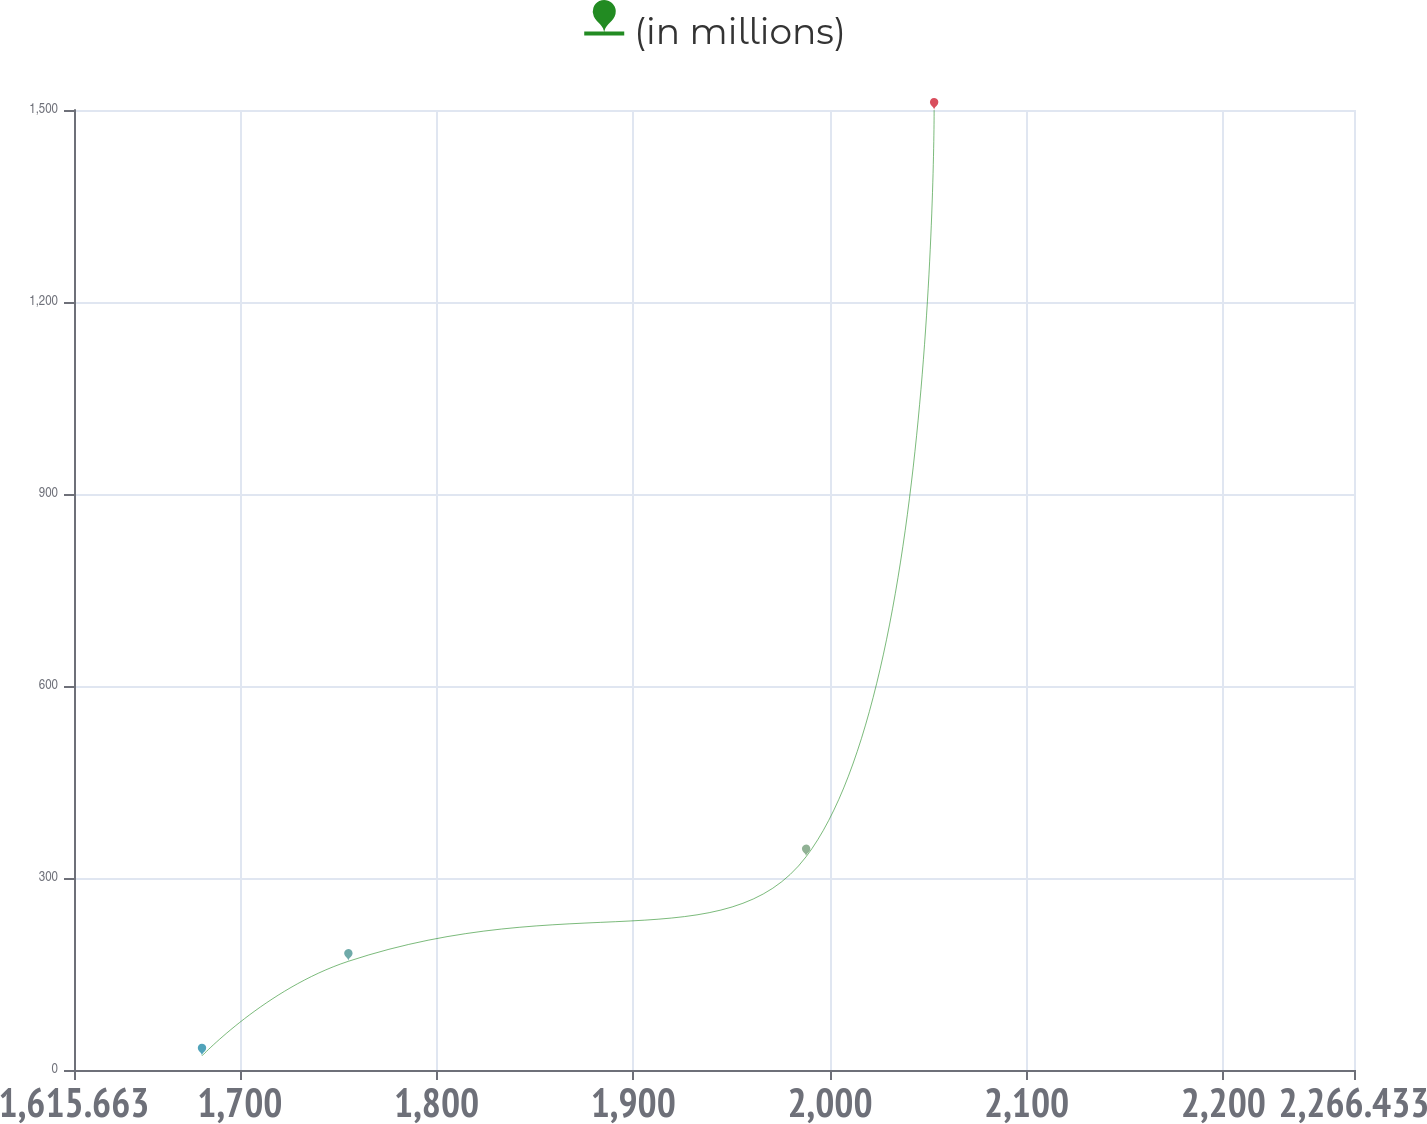Convert chart. <chart><loc_0><loc_0><loc_500><loc_500><line_chart><ecel><fcel>(in millions)<nl><fcel>1680.74<fcel>22.09<nl><fcel>1755.16<fcel>169.87<nl><fcel>1987.89<fcel>333.26<nl><fcel>2052.97<fcel>1499.85<nl><fcel>2331.51<fcel>776.04<nl></chart> 